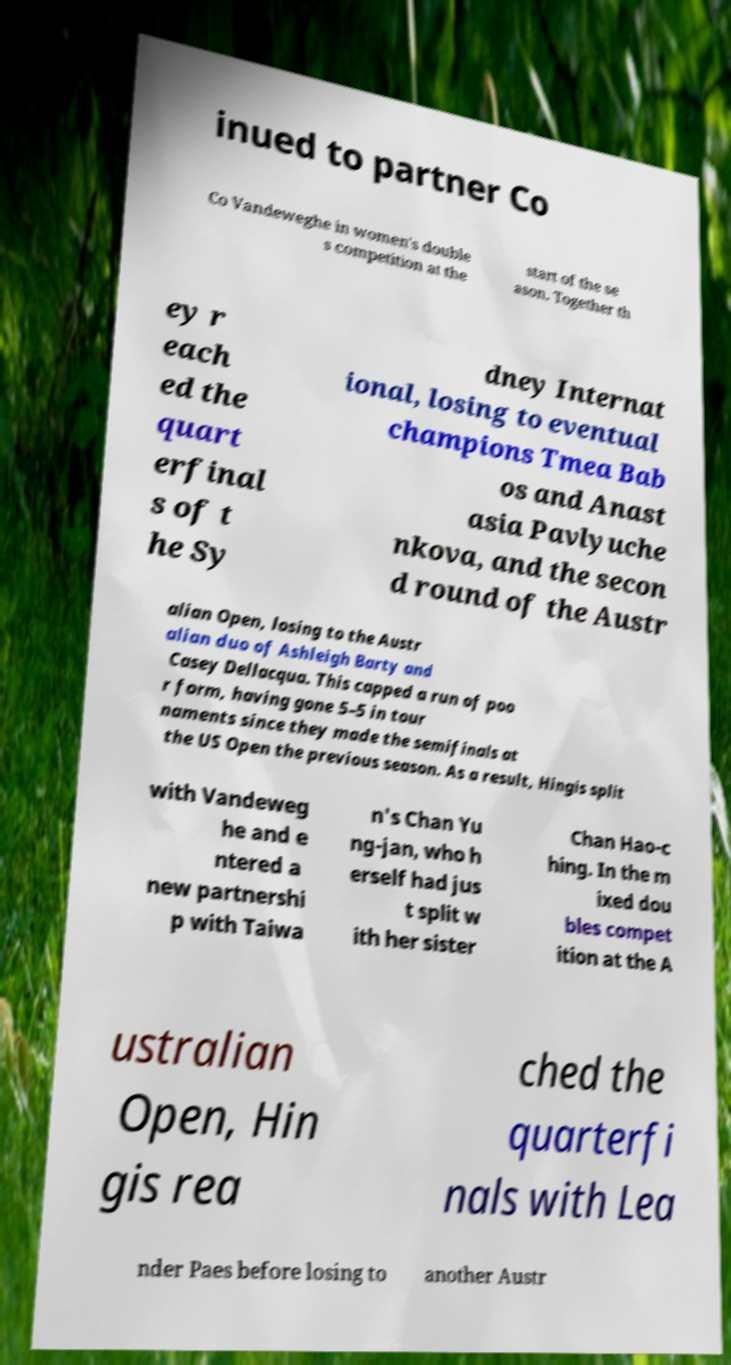There's text embedded in this image that I need extracted. Can you transcribe it verbatim? inued to partner Co Co Vandeweghe in women's double s competition at the start of the se ason. Together th ey r each ed the quart erfinal s of t he Sy dney Internat ional, losing to eventual champions Tmea Bab os and Anast asia Pavlyuche nkova, and the secon d round of the Austr alian Open, losing to the Austr alian duo of Ashleigh Barty and Casey Dellacqua. This capped a run of poo r form, having gone 5–5 in tour naments since they made the semifinals at the US Open the previous season. As a result, Hingis split with Vandeweg he and e ntered a new partnershi p with Taiwa n's Chan Yu ng-jan, who h erself had jus t split w ith her sister Chan Hao-c hing. In the m ixed dou bles compet ition at the A ustralian Open, Hin gis rea ched the quarterfi nals with Lea nder Paes before losing to another Austr 